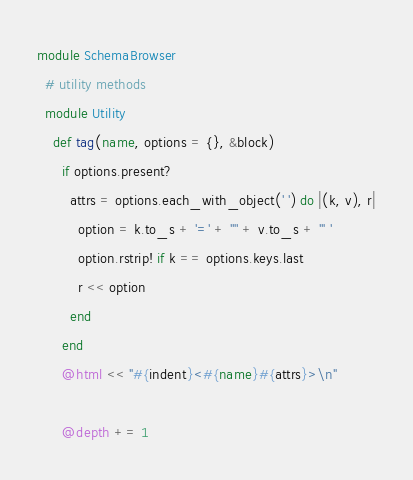<code> <loc_0><loc_0><loc_500><loc_500><_Ruby_>module SchemaBrowser
  # utility methods
  module Utility
    def tag(name, options = {}, &block)
      if options.present?
        attrs = options.each_with_object(' ') do |(k, v), r|
          option = k.to_s + '=' + '"' + v.to_s + '" '
          option.rstrip! if k == options.keys.last
          r << option
        end
      end
      @html << "#{indent}<#{name}#{attrs}>\n"

      @depth += 1</code> 